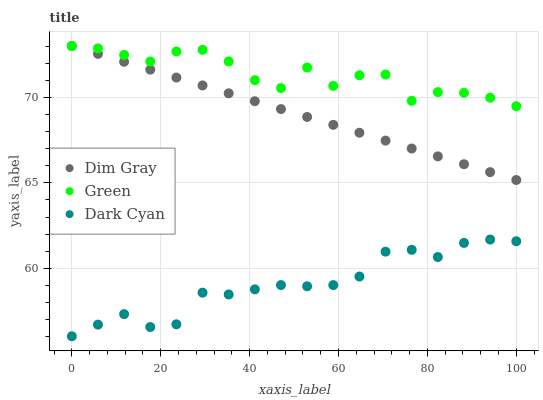Does Dark Cyan have the minimum area under the curve?
Answer yes or no. Yes. Does Green have the maximum area under the curve?
Answer yes or no. Yes. Does Dim Gray have the minimum area under the curve?
Answer yes or no. No. Does Dim Gray have the maximum area under the curve?
Answer yes or no. No. Is Dim Gray the smoothest?
Answer yes or no. Yes. Is Green the roughest?
Answer yes or no. Yes. Is Green the smoothest?
Answer yes or no. No. Is Dim Gray the roughest?
Answer yes or no. No. Does Dark Cyan have the lowest value?
Answer yes or no. Yes. Does Dim Gray have the lowest value?
Answer yes or no. No. Does Green have the highest value?
Answer yes or no. Yes. Is Dark Cyan less than Green?
Answer yes or no. Yes. Is Green greater than Dark Cyan?
Answer yes or no. Yes. Does Dim Gray intersect Green?
Answer yes or no. Yes. Is Dim Gray less than Green?
Answer yes or no. No. Is Dim Gray greater than Green?
Answer yes or no. No. Does Dark Cyan intersect Green?
Answer yes or no. No. 